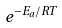Convert formula to latex. <formula><loc_0><loc_0><loc_500><loc_500>e ^ { - E _ { a } / R T }</formula> 